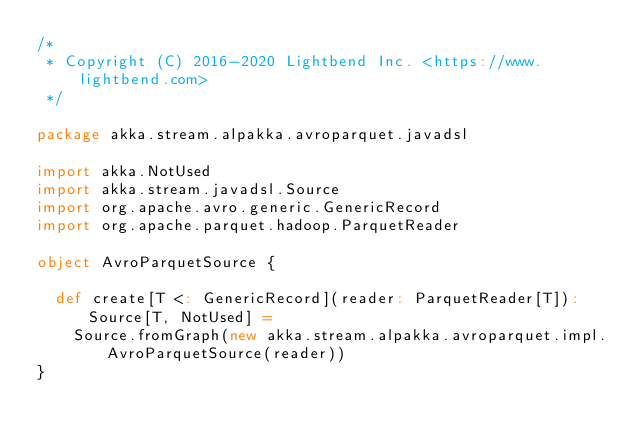Convert code to text. <code><loc_0><loc_0><loc_500><loc_500><_Scala_>/*
 * Copyright (C) 2016-2020 Lightbend Inc. <https://www.lightbend.com>
 */

package akka.stream.alpakka.avroparquet.javadsl

import akka.NotUsed
import akka.stream.javadsl.Source
import org.apache.avro.generic.GenericRecord
import org.apache.parquet.hadoop.ParquetReader

object AvroParquetSource {

  def create[T <: GenericRecord](reader: ParquetReader[T]): Source[T, NotUsed] =
    Source.fromGraph(new akka.stream.alpakka.avroparquet.impl.AvroParquetSource(reader))
}
</code> 